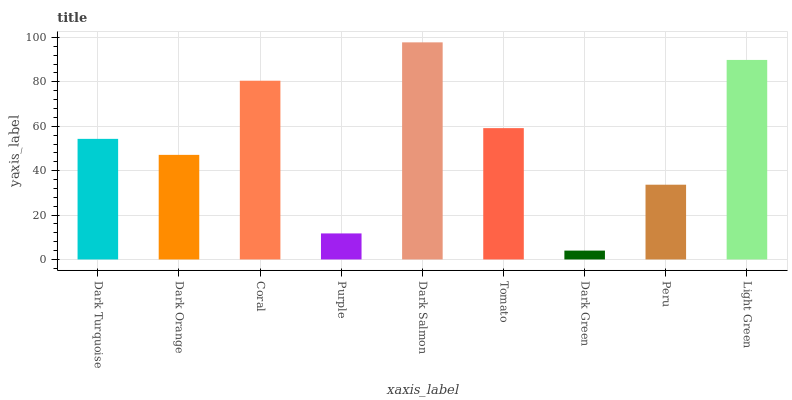Is Dark Green the minimum?
Answer yes or no. Yes. Is Dark Salmon the maximum?
Answer yes or no. Yes. Is Dark Orange the minimum?
Answer yes or no. No. Is Dark Orange the maximum?
Answer yes or no. No. Is Dark Turquoise greater than Dark Orange?
Answer yes or no. Yes. Is Dark Orange less than Dark Turquoise?
Answer yes or no. Yes. Is Dark Orange greater than Dark Turquoise?
Answer yes or no. No. Is Dark Turquoise less than Dark Orange?
Answer yes or no. No. Is Dark Turquoise the high median?
Answer yes or no. Yes. Is Dark Turquoise the low median?
Answer yes or no. Yes. Is Dark Orange the high median?
Answer yes or no. No. Is Purple the low median?
Answer yes or no. No. 